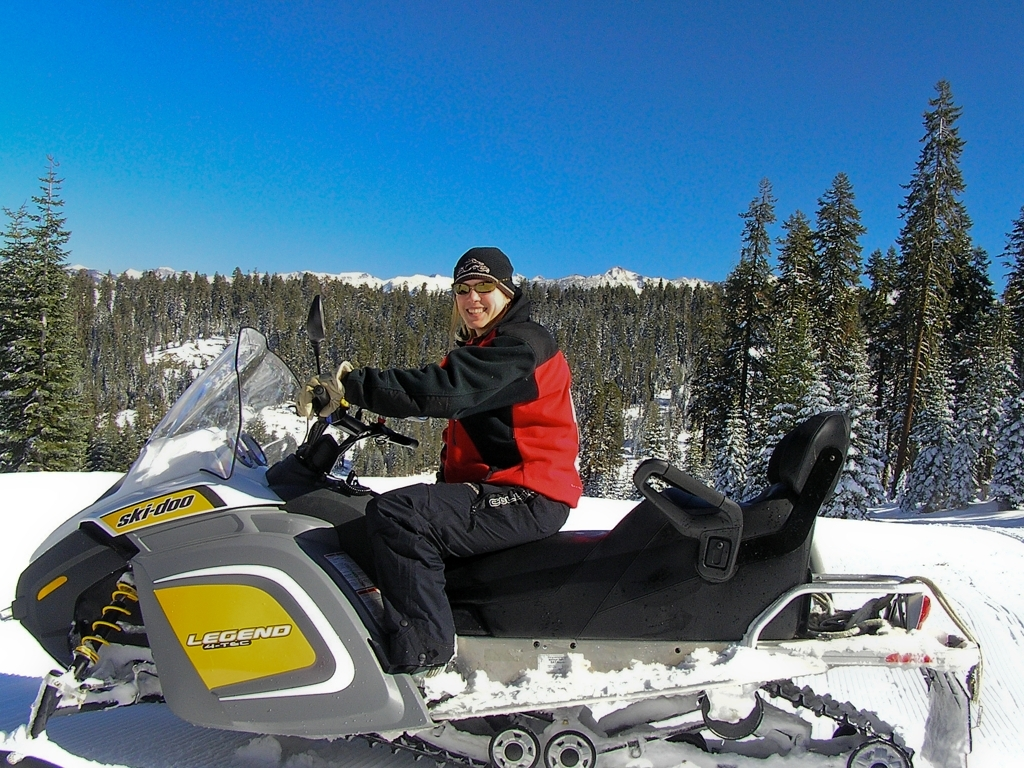What kind of environment or landscape is best for snowmobiling? Ideal snowmobiling environments include snowy landscapes with plenty of open space to maneuver, such as frozen lakes, open fields, and groomed trails through forests. It's important that the area has a solid base of packed snow, and many enthusiasts enjoy regions with scenic views and varied terrain, similar to the mountainous backdrop seen in the image. 